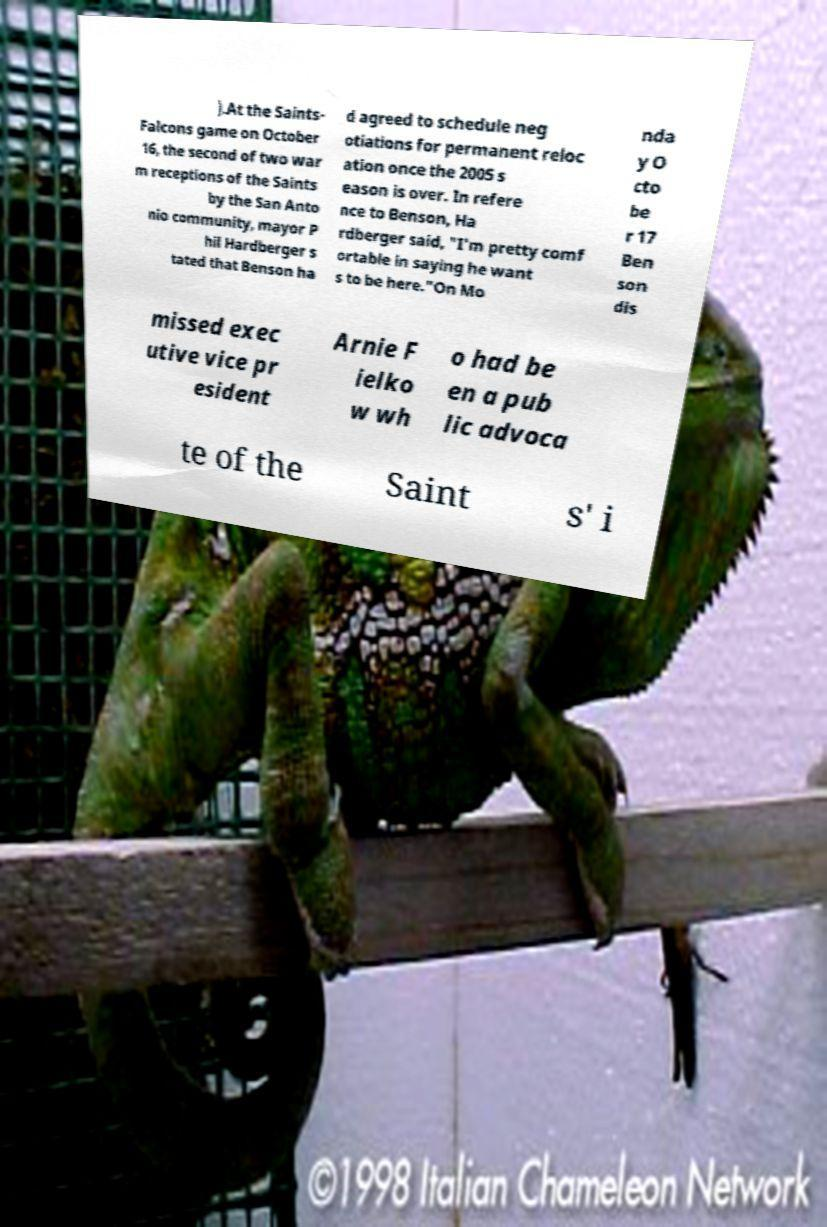Please identify and transcribe the text found in this image. ).At the Saints- Falcons game on October 16, the second of two war m receptions of the Saints by the San Anto nio community, mayor P hil Hardberger s tated that Benson ha d agreed to schedule neg otiations for permanent reloc ation once the 2005 s eason is over. In refere nce to Benson, Ha rdberger said, "I'm pretty comf ortable in saying he want s to be here."On Mo nda y O cto be r 17 Ben son dis missed exec utive vice pr esident Arnie F ielko w wh o had be en a pub lic advoca te of the Saint s' i 